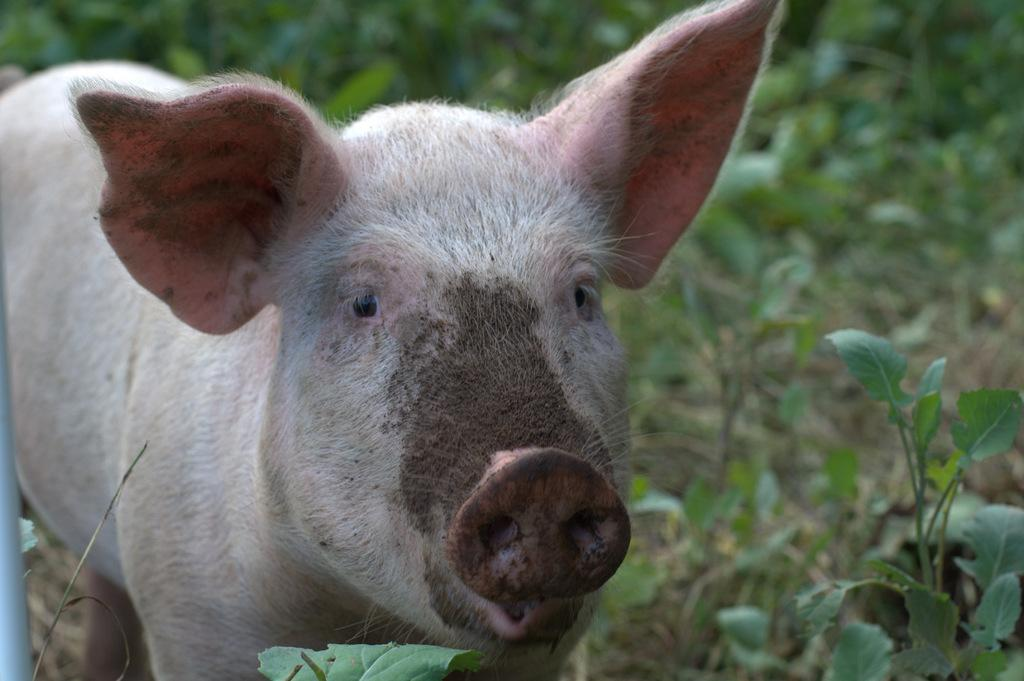What animal is present in the image? There is a pig in the image. Can you describe the position of the pig in the image? The pig is standing in the front. What type of vegetation can be seen in the background of the image? There are plants in the background of the image. What type of holiday is being celebrated in the image? There is no indication of a holiday being celebrated in the image. What is the pig using to sweeten its food in the image? There is no mention of honey or any other sweetener in the image. 